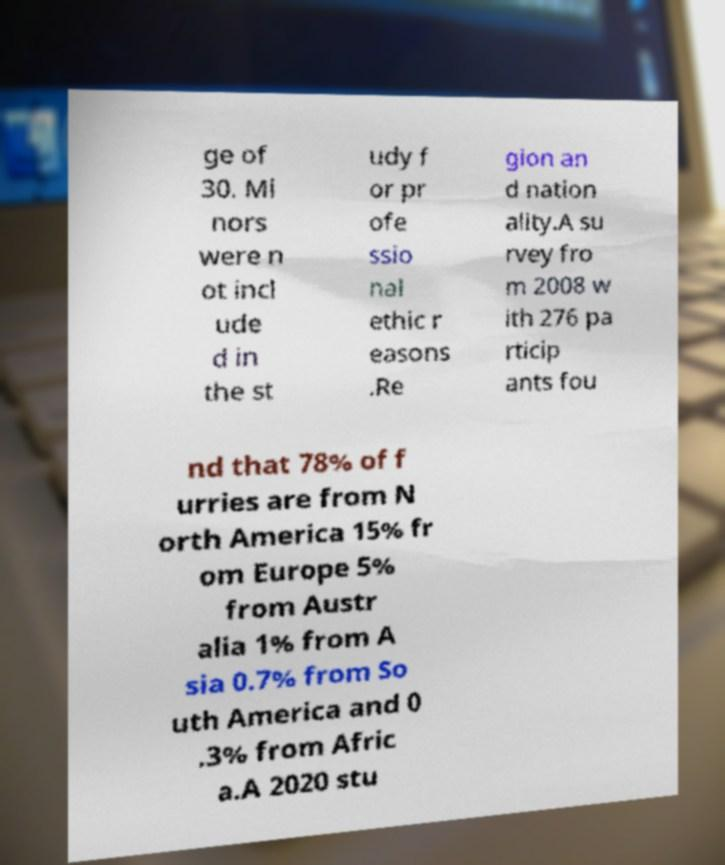For documentation purposes, I need the text within this image transcribed. Could you provide that? ge of 30. Mi nors were n ot incl ude d in the st udy f or pr ofe ssio nal ethic r easons .Re gion an d nation ality.A su rvey fro m 2008 w ith 276 pa rticip ants fou nd that 78% of f urries are from N orth America 15% fr om Europe 5% from Austr alia 1% from A sia 0.7% from So uth America and 0 .3% from Afric a.A 2020 stu 